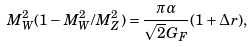<formula> <loc_0><loc_0><loc_500><loc_500>M _ { W } ^ { 2 } ( 1 - M _ { W } ^ { 2 } / M _ { Z } ^ { 2 } ) = \frac { \pi \alpha } { \sqrt { 2 } G _ { F } } ( 1 + { \mathit \Delta } r ) ,</formula> 